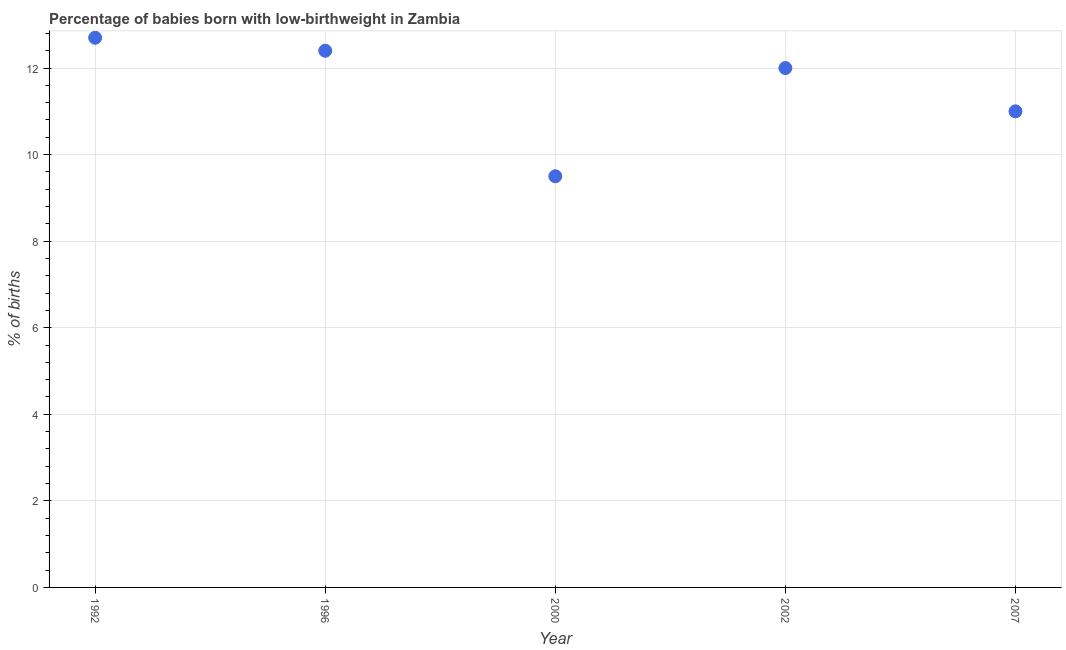In which year was the percentage of babies who were born with low-birthweight maximum?
Ensure brevity in your answer.  1992. In which year was the percentage of babies who were born with low-birthweight minimum?
Your answer should be very brief. 2000. What is the sum of the percentage of babies who were born with low-birthweight?
Offer a terse response. 57.6. What is the difference between the percentage of babies who were born with low-birthweight in 1996 and 2002?
Provide a succinct answer. 0.4. What is the average percentage of babies who were born with low-birthweight per year?
Your answer should be very brief. 11.52. In how many years, is the percentage of babies who were born with low-birthweight greater than 6.4 %?
Keep it short and to the point. 5. What is the ratio of the percentage of babies who were born with low-birthweight in 1996 to that in 2000?
Your response must be concise. 1.31. Is the difference between the percentage of babies who were born with low-birthweight in 2000 and 2007 greater than the difference between any two years?
Provide a short and direct response. No. What is the difference between the highest and the second highest percentage of babies who were born with low-birthweight?
Provide a short and direct response. 0.3. Is the sum of the percentage of babies who were born with low-birthweight in 1996 and 2002 greater than the maximum percentage of babies who were born with low-birthweight across all years?
Your answer should be compact. Yes. What is the difference between the highest and the lowest percentage of babies who were born with low-birthweight?
Keep it short and to the point. 3.2. How many dotlines are there?
Make the answer very short. 1. What is the difference between two consecutive major ticks on the Y-axis?
Your response must be concise. 2. Does the graph contain any zero values?
Provide a succinct answer. No. What is the title of the graph?
Your answer should be compact. Percentage of babies born with low-birthweight in Zambia. What is the label or title of the Y-axis?
Your answer should be compact. % of births. What is the % of births in 1992?
Your response must be concise. 12.7. What is the % of births in 1996?
Your answer should be compact. 12.4. What is the difference between the % of births in 1992 and 1996?
Offer a terse response. 0.3. What is the difference between the % of births in 1992 and 2000?
Make the answer very short. 3.2. What is the difference between the % of births in 1996 and 2000?
Your answer should be very brief. 2.9. What is the difference between the % of births in 2000 and 2002?
Your answer should be compact. -2.5. What is the ratio of the % of births in 1992 to that in 1996?
Provide a succinct answer. 1.02. What is the ratio of the % of births in 1992 to that in 2000?
Make the answer very short. 1.34. What is the ratio of the % of births in 1992 to that in 2002?
Your response must be concise. 1.06. What is the ratio of the % of births in 1992 to that in 2007?
Keep it short and to the point. 1.16. What is the ratio of the % of births in 1996 to that in 2000?
Your answer should be compact. 1.3. What is the ratio of the % of births in 1996 to that in 2002?
Give a very brief answer. 1.03. What is the ratio of the % of births in 1996 to that in 2007?
Provide a succinct answer. 1.13. What is the ratio of the % of births in 2000 to that in 2002?
Provide a succinct answer. 0.79. What is the ratio of the % of births in 2000 to that in 2007?
Make the answer very short. 0.86. What is the ratio of the % of births in 2002 to that in 2007?
Offer a terse response. 1.09. 